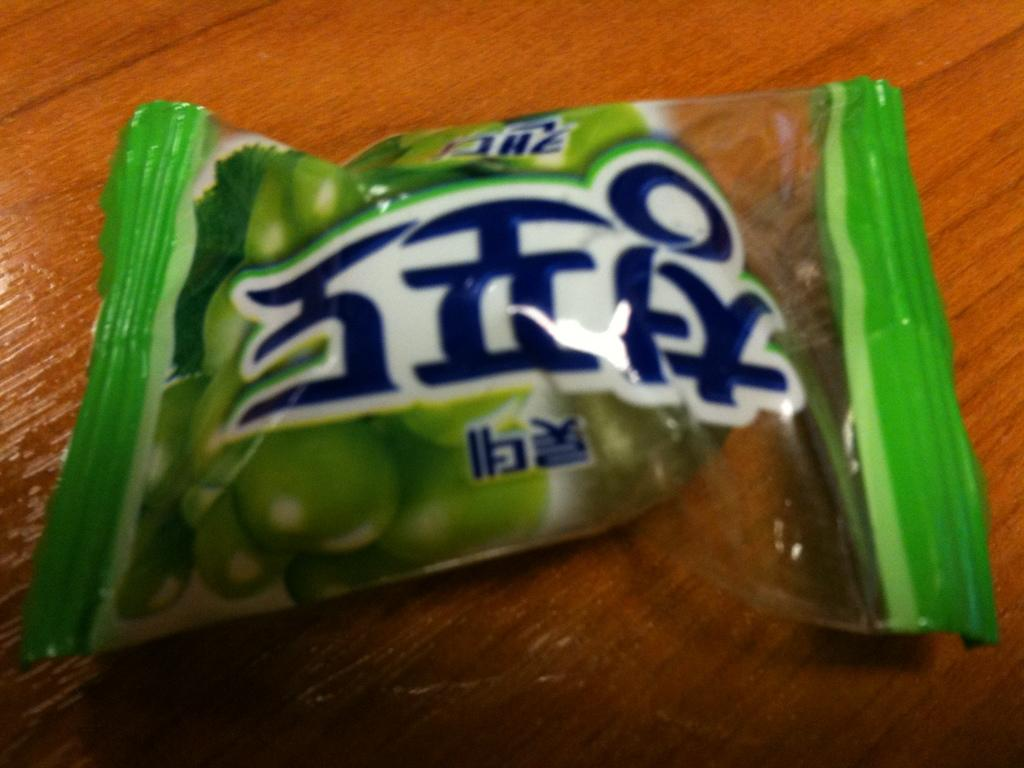<image>
Write a terse but informative summary of the picture. A green packet of items that has foreign text on it. 